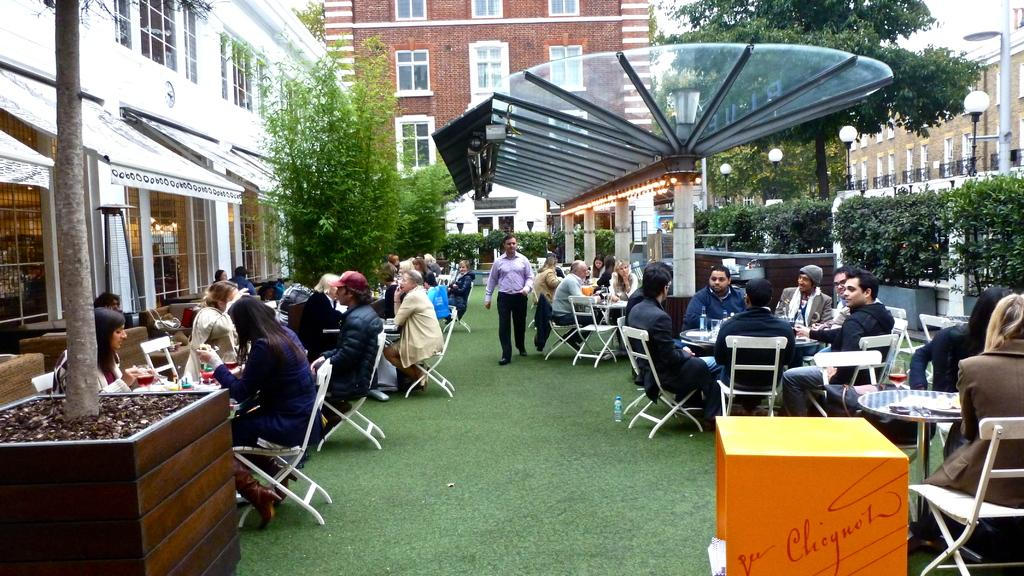How many people are in the image? There is a group of people in the image. What are the people doing in the image? The people are sitting on chairs. How are the chairs arranged in the image? The chairs are arranged around a table. What can be seen near the people in the image? There are plants in the vicinity of the people. What type of road can be seen in the image? There is no road present in the image. How many ranges of mountains are visible in the image? There are no mountains or ranges present in the image. 